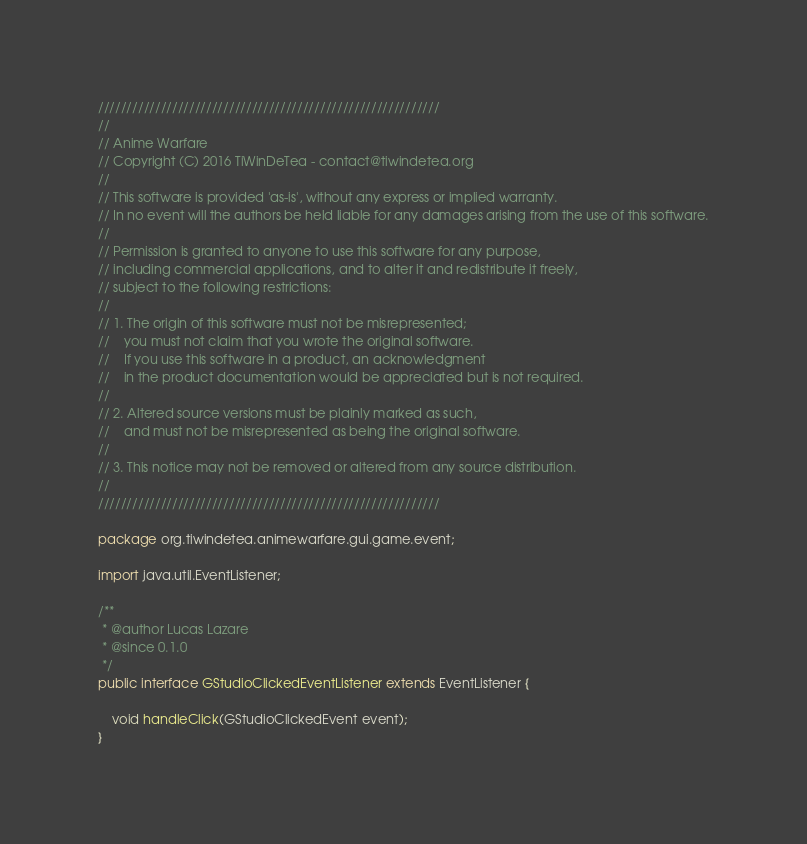<code> <loc_0><loc_0><loc_500><loc_500><_Java_>////////////////////////////////////////////////////////////
//
// Anime Warfare
// Copyright (C) 2016 TiWinDeTea - contact@tiwindetea.org
//
// This software is provided 'as-is', without any express or implied warranty.
// In no event will the authors be held liable for any damages arising from the use of this software.
//
// Permission is granted to anyone to use this software for any purpose,
// including commercial applications, and to alter it and redistribute it freely,
// subject to the following restrictions:
//
// 1. The origin of this software must not be misrepresented;
//    you must not claim that you wrote the original software.
//    If you use this software in a product, an acknowledgment
//    in the product documentation would be appreciated but is not required.
//
// 2. Altered source versions must be plainly marked as such,
//    and must not be misrepresented as being the original software.
//
// 3. This notice may not be removed or altered from any source distribution.
//
////////////////////////////////////////////////////////////

package org.tiwindetea.animewarfare.gui.game.event;

import java.util.EventListener;

/**
 * @author Lucas Lazare
 * @since 0.1.0
 */
public interface GStudioClickedEventListener extends EventListener {

    void handleClick(GStudioClickedEvent event);
}
</code> 